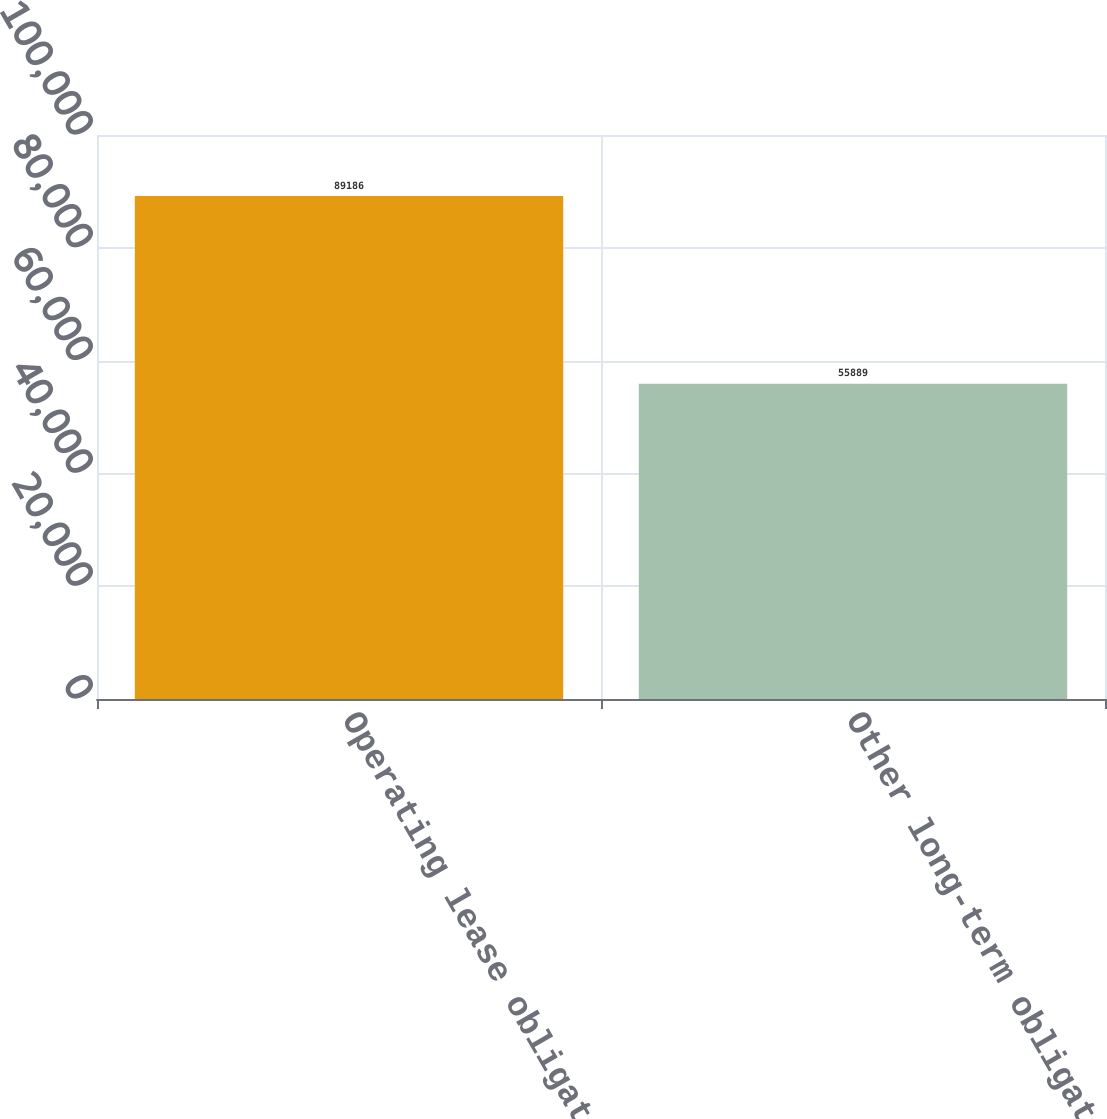Convert chart. <chart><loc_0><loc_0><loc_500><loc_500><bar_chart><fcel>Operating lease obligations<fcel>Other long-term obligations<nl><fcel>89186<fcel>55889<nl></chart> 